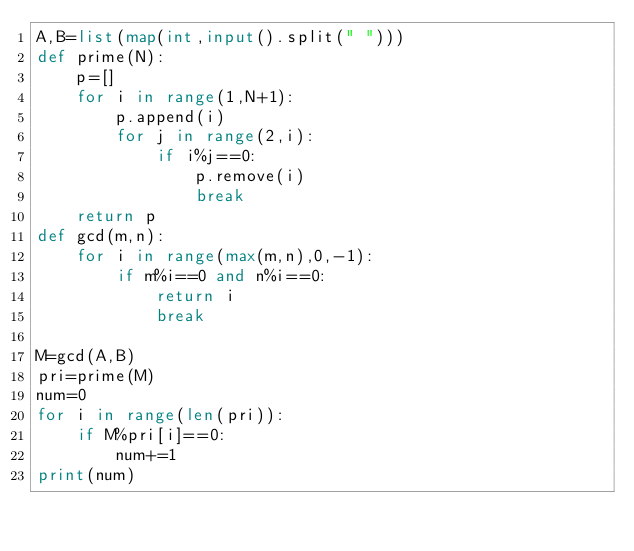<code> <loc_0><loc_0><loc_500><loc_500><_Python_>A,B=list(map(int,input().split(" ")))
def prime(N):
    p=[]
    for i in range(1,N+1):
        p.append(i)
        for j in range(2,i):
            if i%j==0:
                p.remove(i)
                break
    return p
def gcd(m,n):
    for i in range(max(m,n),0,-1):
        if m%i==0 and n%i==0:
            return i
            break

M=gcd(A,B)
pri=prime(M)
num=0
for i in range(len(pri)):
    if M%pri[i]==0:
        num+=1
print(num)
</code> 